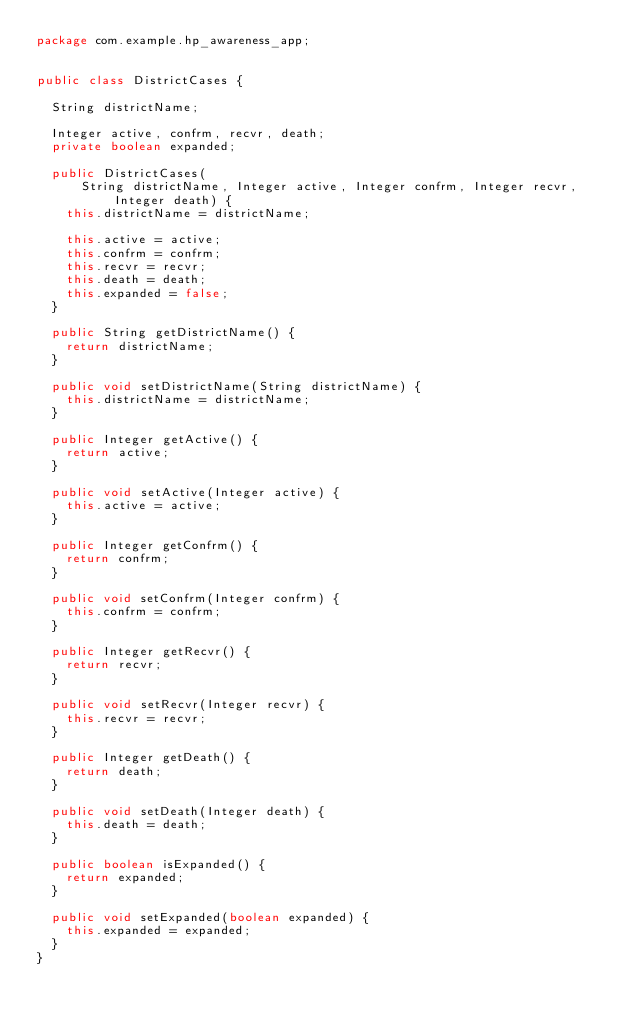Convert code to text. <code><loc_0><loc_0><loc_500><loc_500><_Java_>package com.example.hp_awareness_app;


public class DistrictCases {

  String districtName;

  Integer active, confrm, recvr, death;
  private boolean expanded;

  public DistrictCases(
      String districtName, Integer active, Integer confrm, Integer recvr, Integer death) {
    this.districtName = districtName;

    this.active = active;
    this.confrm = confrm;
    this.recvr = recvr;
    this.death = death;
    this.expanded = false;
  }

  public String getDistrictName() {
    return districtName;
  }

  public void setDistrictName(String districtName) {
    this.districtName = districtName;
  }

  public Integer getActive() {
    return active;
  }

  public void setActive(Integer active) {
    this.active = active;
  }

  public Integer getConfrm() {
    return confrm;
  }

  public void setConfrm(Integer confrm) {
    this.confrm = confrm;
  }

  public Integer getRecvr() {
    return recvr;
  }

  public void setRecvr(Integer recvr) {
    this.recvr = recvr;
  }

  public Integer getDeath() {
    return death;
  }

  public void setDeath(Integer death) {
    this.death = death;
  }

  public boolean isExpanded() {
    return expanded;
  }

  public void setExpanded(boolean expanded) {
    this.expanded = expanded;
  }
}
</code> 